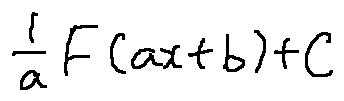<formula> <loc_0><loc_0><loc_500><loc_500>\frac { 1 } { a } F ( a x + b ) + C</formula> 